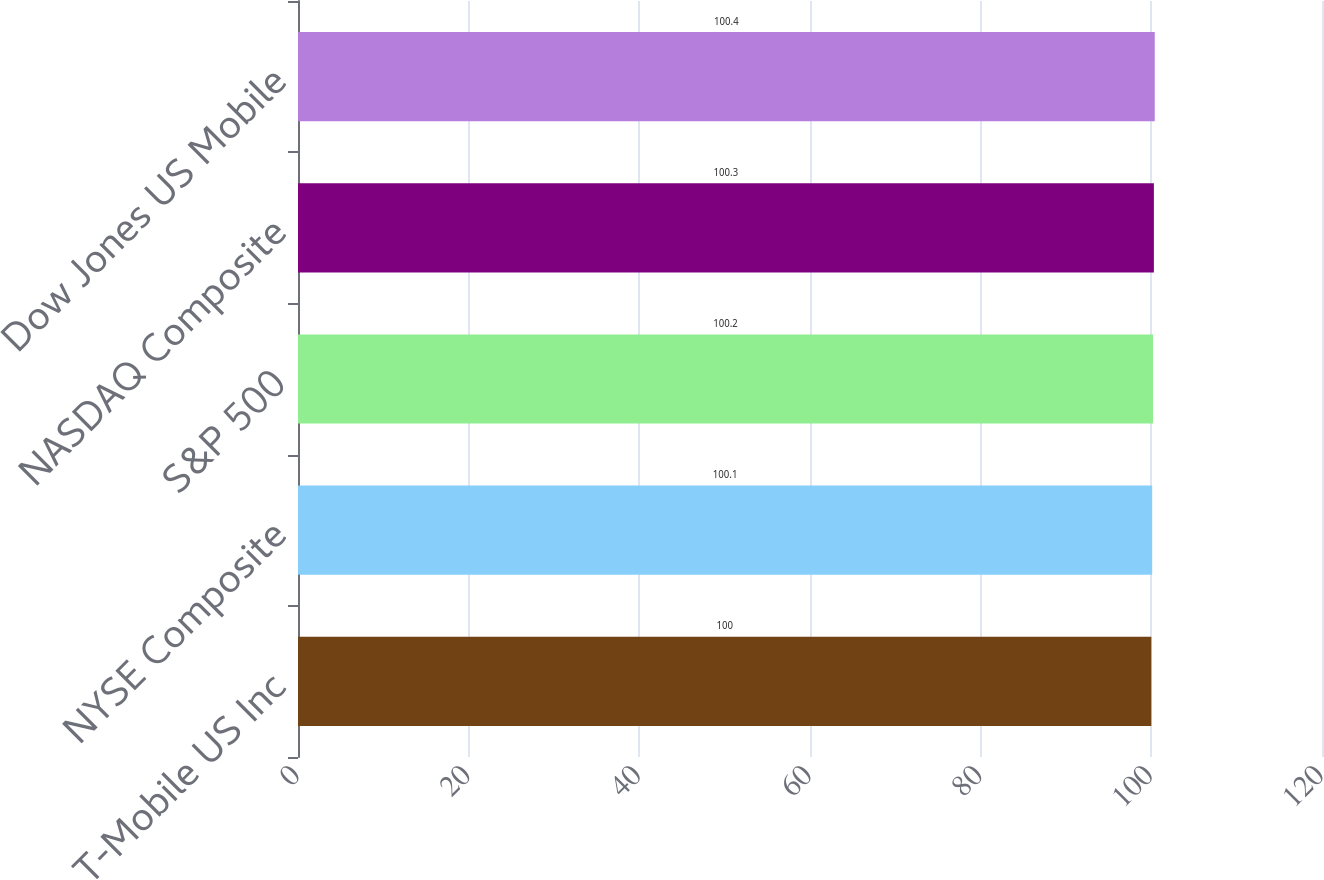<chart> <loc_0><loc_0><loc_500><loc_500><bar_chart><fcel>T-Mobile US Inc<fcel>NYSE Composite<fcel>S&P 500<fcel>NASDAQ Composite<fcel>Dow Jones US Mobile<nl><fcel>100<fcel>100.1<fcel>100.2<fcel>100.3<fcel>100.4<nl></chart> 